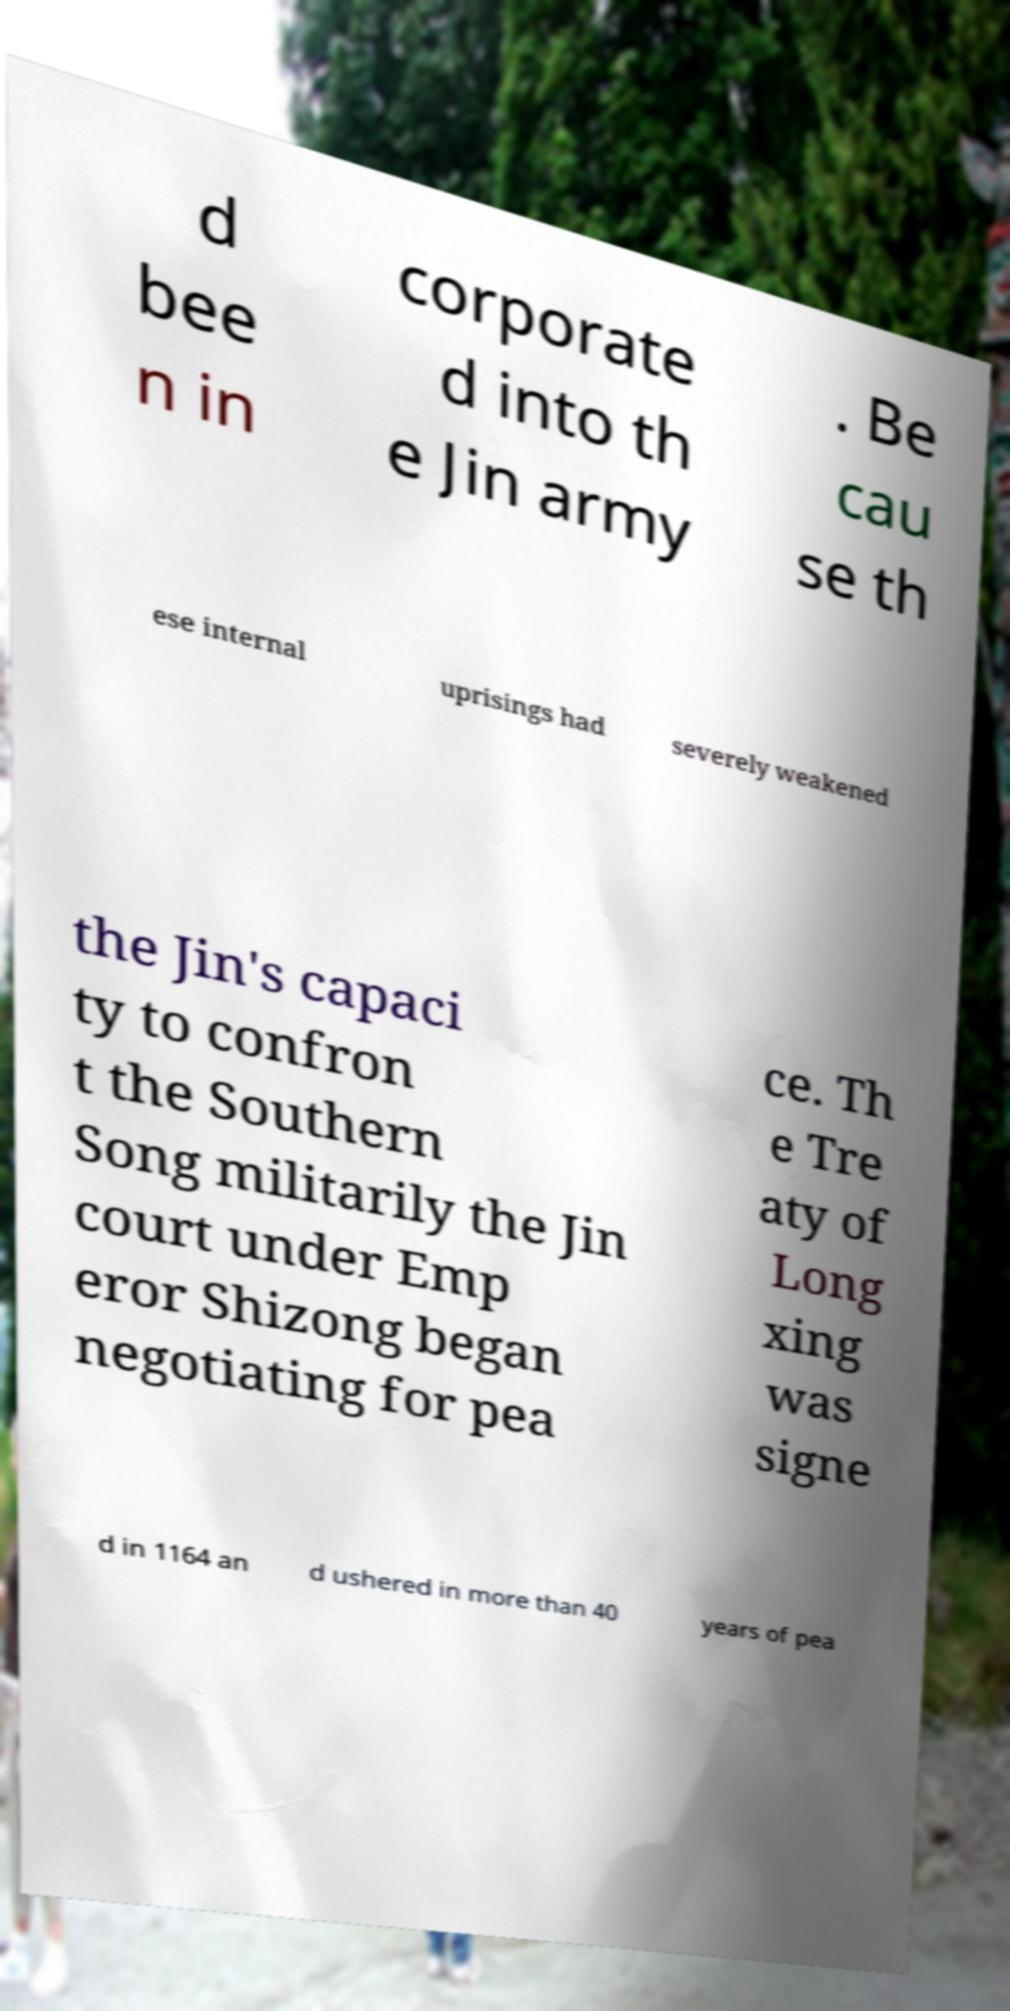There's text embedded in this image that I need extracted. Can you transcribe it verbatim? d bee n in corporate d into th e Jin army . Be cau se th ese internal uprisings had severely weakened the Jin's capaci ty to confron t the Southern Song militarily the Jin court under Emp eror Shizong began negotiating for pea ce. Th e Tre aty of Long xing was signe d in 1164 an d ushered in more than 40 years of pea 